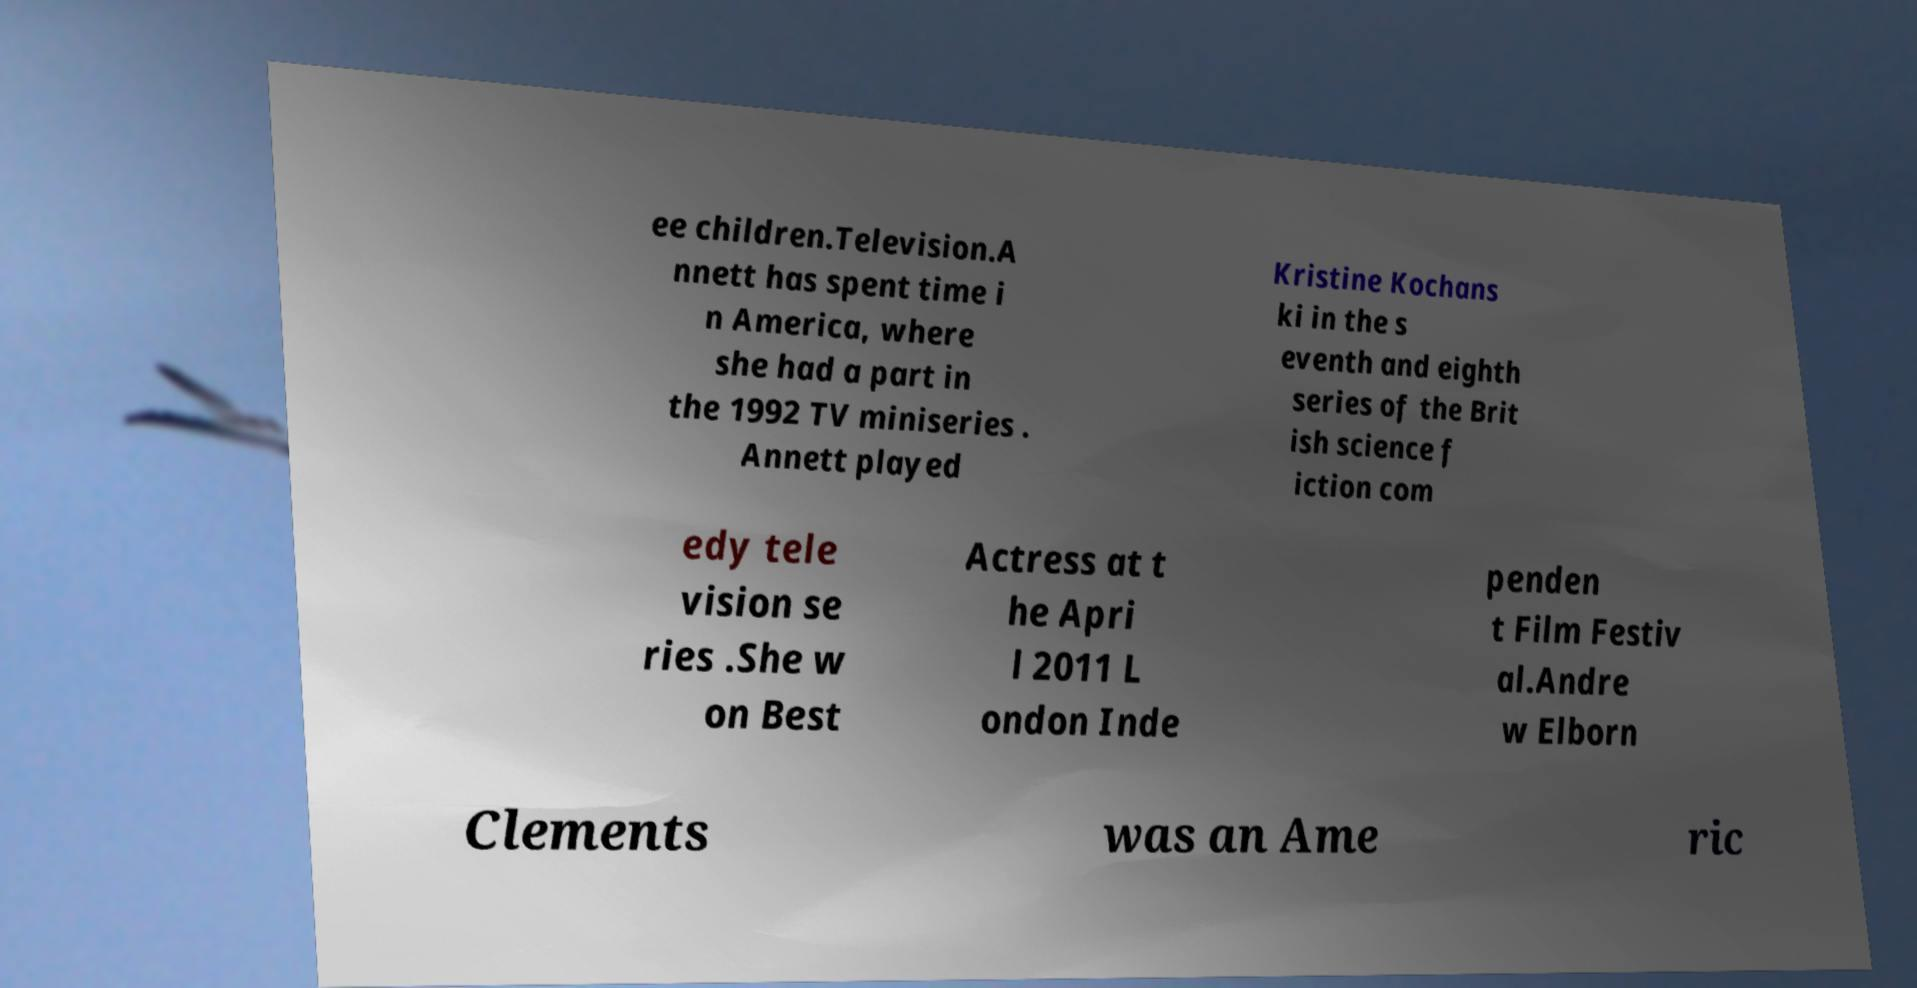Can you read and provide the text displayed in the image?This photo seems to have some interesting text. Can you extract and type it out for me? ee children.Television.A nnett has spent time i n America, where she had a part in the 1992 TV miniseries . Annett played Kristine Kochans ki in the s eventh and eighth series of the Brit ish science f iction com edy tele vision se ries .She w on Best Actress at t he Apri l 2011 L ondon Inde penden t Film Festiv al.Andre w Elborn Clements was an Ame ric 